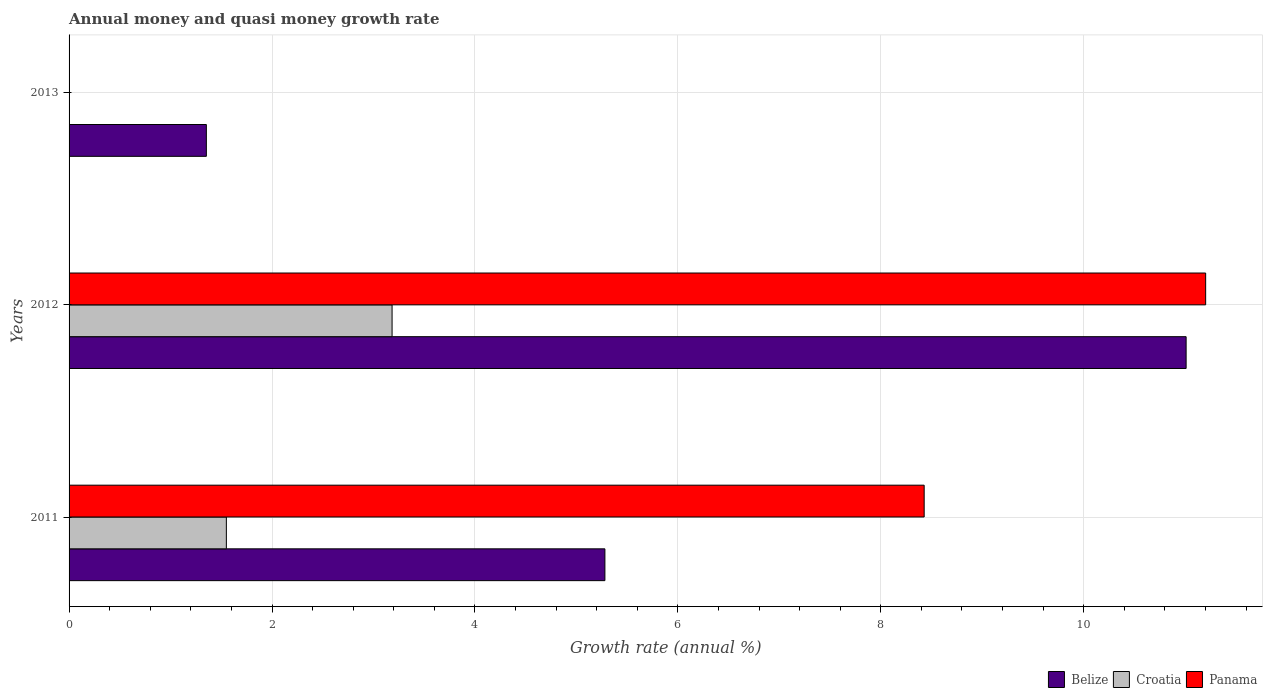Are the number of bars per tick equal to the number of legend labels?
Keep it short and to the point. No. Are the number of bars on each tick of the Y-axis equal?
Offer a terse response. No. How many bars are there on the 2nd tick from the top?
Your answer should be very brief. 3. In how many cases, is the number of bars for a given year not equal to the number of legend labels?
Offer a very short reply. 1. What is the growth rate in Panama in 2012?
Provide a succinct answer. 11.2. Across all years, what is the maximum growth rate in Belize?
Keep it short and to the point. 11.01. Across all years, what is the minimum growth rate in Belize?
Offer a terse response. 1.35. In which year was the growth rate in Belize maximum?
Provide a succinct answer. 2012. What is the total growth rate in Belize in the graph?
Give a very brief answer. 17.64. What is the difference between the growth rate in Panama in 2011 and that in 2012?
Give a very brief answer. -2.77. What is the difference between the growth rate in Croatia in 2013 and the growth rate in Belize in 2012?
Your answer should be compact. -11.01. What is the average growth rate in Croatia per year?
Provide a succinct answer. 1.58. In the year 2012, what is the difference between the growth rate in Croatia and growth rate in Belize?
Make the answer very short. -7.83. In how many years, is the growth rate in Belize greater than 2.8 %?
Give a very brief answer. 2. What is the ratio of the growth rate in Croatia in 2011 to that in 2012?
Your answer should be very brief. 0.49. What is the difference between the highest and the second highest growth rate in Belize?
Your response must be concise. 5.73. What is the difference between the highest and the lowest growth rate in Croatia?
Your answer should be compact. 3.18. Are all the bars in the graph horizontal?
Offer a very short reply. Yes. Are the values on the major ticks of X-axis written in scientific E-notation?
Ensure brevity in your answer.  No. Does the graph contain any zero values?
Make the answer very short. Yes. Does the graph contain grids?
Provide a succinct answer. Yes. Where does the legend appear in the graph?
Offer a terse response. Bottom right. How many legend labels are there?
Give a very brief answer. 3. How are the legend labels stacked?
Make the answer very short. Horizontal. What is the title of the graph?
Keep it short and to the point. Annual money and quasi money growth rate. What is the label or title of the X-axis?
Your answer should be very brief. Growth rate (annual %). What is the Growth rate (annual %) in Belize in 2011?
Provide a short and direct response. 5.28. What is the Growth rate (annual %) in Croatia in 2011?
Make the answer very short. 1.55. What is the Growth rate (annual %) of Panama in 2011?
Provide a short and direct response. 8.43. What is the Growth rate (annual %) of Belize in 2012?
Give a very brief answer. 11.01. What is the Growth rate (annual %) of Croatia in 2012?
Your answer should be very brief. 3.18. What is the Growth rate (annual %) of Panama in 2012?
Provide a short and direct response. 11.2. What is the Growth rate (annual %) of Belize in 2013?
Your answer should be compact. 1.35. What is the Growth rate (annual %) of Croatia in 2013?
Your answer should be compact. 0. Across all years, what is the maximum Growth rate (annual %) of Belize?
Provide a succinct answer. 11.01. Across all years, what is the maximum Growth rate (annual %) in Croatia?
Offer a terse response. 3.18. Across all years, what is the maximum Growth rate (annual %) of Panama?
Provide a succinct answer. 11.2. Across all years, what is the minimum Growth rate (annual %) in Belize?
Make the answer very short. 1.35. What is the total Growth rate (annual %) of Belize in the graph?
Make the answer very short. 17.64. What is the total Growth rate (annual %) of Croatia in the graph?
Your response must be concise. 4.73. What is the total Growth rate (annual %) of Panama in the graph?
Provide a succinct answer. 19.63. What is the difference between the Growth rate (annual %) of Belize in 2011 and that in 2012?
Provide a short and direct response. -5.73. What is the difference between the Growth rate (annual %) in Croatia in 2011 and that in 2012?
Give a very brief answer. -1.63. What is the difference between the Growth rate (annual %) in Panama in 2011 and that in 2012?
Provide a succinct answer. -2.77. What is the difference between the Growth rate (annual %) of Belize in 2011 and that in 2013?
Offer a terse response. 3.93. What is the difference between the Growth rate (annual %) in Belize in 2012 and that in 2013?
Keep it short and to the point. 9.66. What is the difference between the Growth rate (annual %) of Belize in 2011 and the Growth rate (annual %) of Croatia in 2012?
Offer a terse response. 2.1. What is the difference between the Growth rate (annual %) in Belize in 2011 and the Growth rate (annual %) in Panama in 2012?
Provide a succinct answer. -5.92. What is the difference between the Growth rate (annual %) of Croatia in 2011 and the Growth rate (annual %) of Panama in 2012?
Ensure brevity in your answer.  -9.65. What is the average Growth rate (annual %) in Belize per year?
Offer a terse response. 5.88. What is the average Growth rate (annual %) in Croatia per year?
Offer a very short reply. 1.58. What is the average Growth rate (annual %) of Panama per year?
Your response must be concise. 6.54. In the year 2011, what is the difference between the Growth rate (annual %) of Belize and Growth rate (annual %) of Croatia?
Keep it short and to the point. 3.73. In the year 2011, what is the difference between the Growth rate (annual %) in Belize and Growth rate (annual %) in Panama?
Make the answer very short. -3.15. In the year 2011, what is the difference between the Growth rate (annual %) of Croatia and Growth rate (annual %) of Panama?
Your response must be concise. -6.88. In the year 2012, what is the difference between the Growth rate (annual %) of Belize and Growth rate (annual %) of Croatia?
Your answer should be compact. 7.83. In the year 2012, what is the difference between the Growth rate (annual %) of Belize and Growth rate (annual %) of Panama?
Your response must be concise. -0.19. In the year 2012, what is the difference between the Growth rate (annual %) of Croatia and Growth rate (annual %) of Panama?
Keep it short and to the point. -8.02. What is the ratio of the Growth rate (annual %) in Belize in 2011 to that in 2012?
Your response must be concise. 0.48. What is the ratio of the Growth rate (annual %) of Croatia in 2011 to that in 2012?
Make the answer very short. 0.49. What is the ratio of the Growth rate (annual %) of Panama in 2011 to that in 2012?
Your answer should be very brief. 0.75. What is the ratio of the Growth rate (annual %) of Belize in 2011 to that in 2013?
Your response must be concise. 3.9. What is the ratio of the Growth rate (annual %) of Belize in 2012 to that in 2013?
Offer a very short reply. 8.14. What is the difference between the highest and the second highest Growth rate (annual %) of Belize?
Provide a short and direct response. 5.73. What is the difference between the highest and the lowest Growth rate (annual %) of Belize?
Your answer should be compact. 9.66. What is the difference between the highest and the lowest Growth rate (annual %) in Croatia?
Offer a terse response. 3.18. What is the difference between the highest and the lowest Growth rate (annual %) in Panama?
Ensure brevity in your answer.  11.2. 